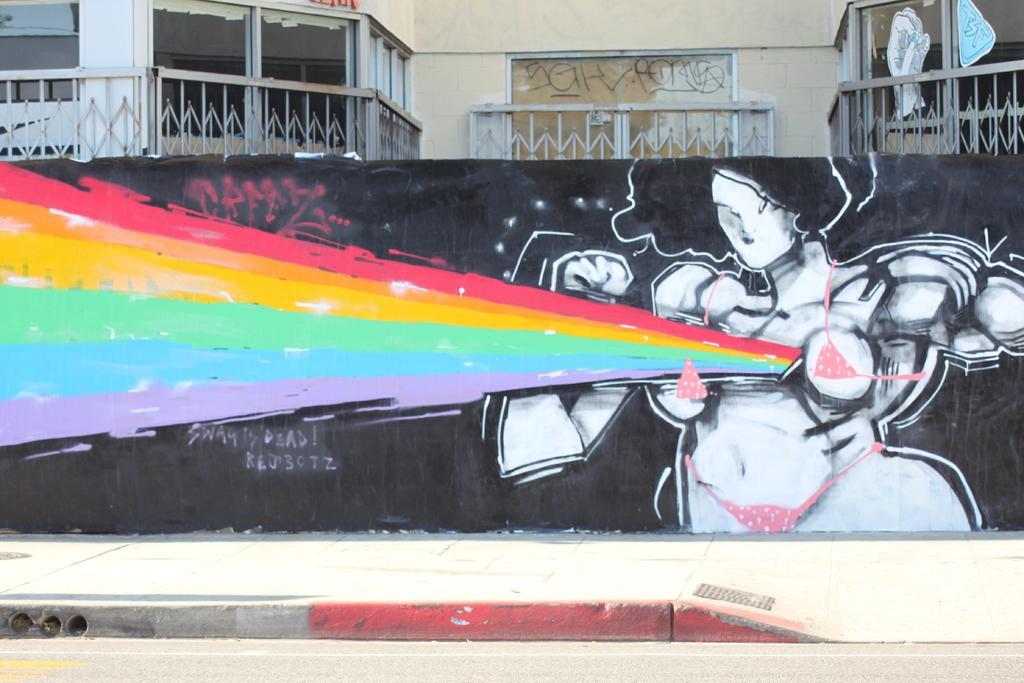Can you describe this image briefly? In the image in the center there is a road and wall. On the wall,we can see graffiti. In the background there is a building,windows,posters,fences etc. 